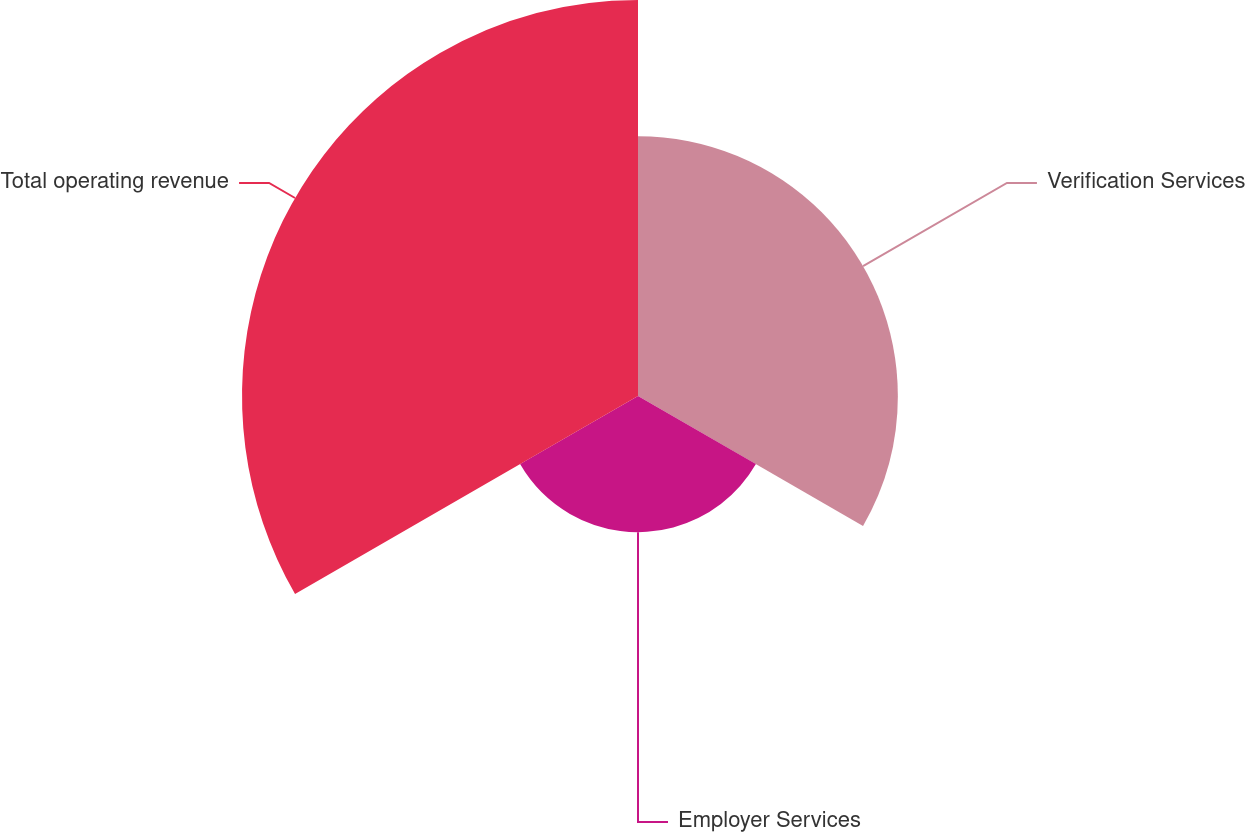<chart> <loc_0><loc_0><loc_500><loc_500><pie_chart><fcel>Verification Services<fcel>Employer Services<fcel>Total operating revenue<nl><fcel>32.81%<fcel>17.19%<fcel>50.0%<nl></chart> 